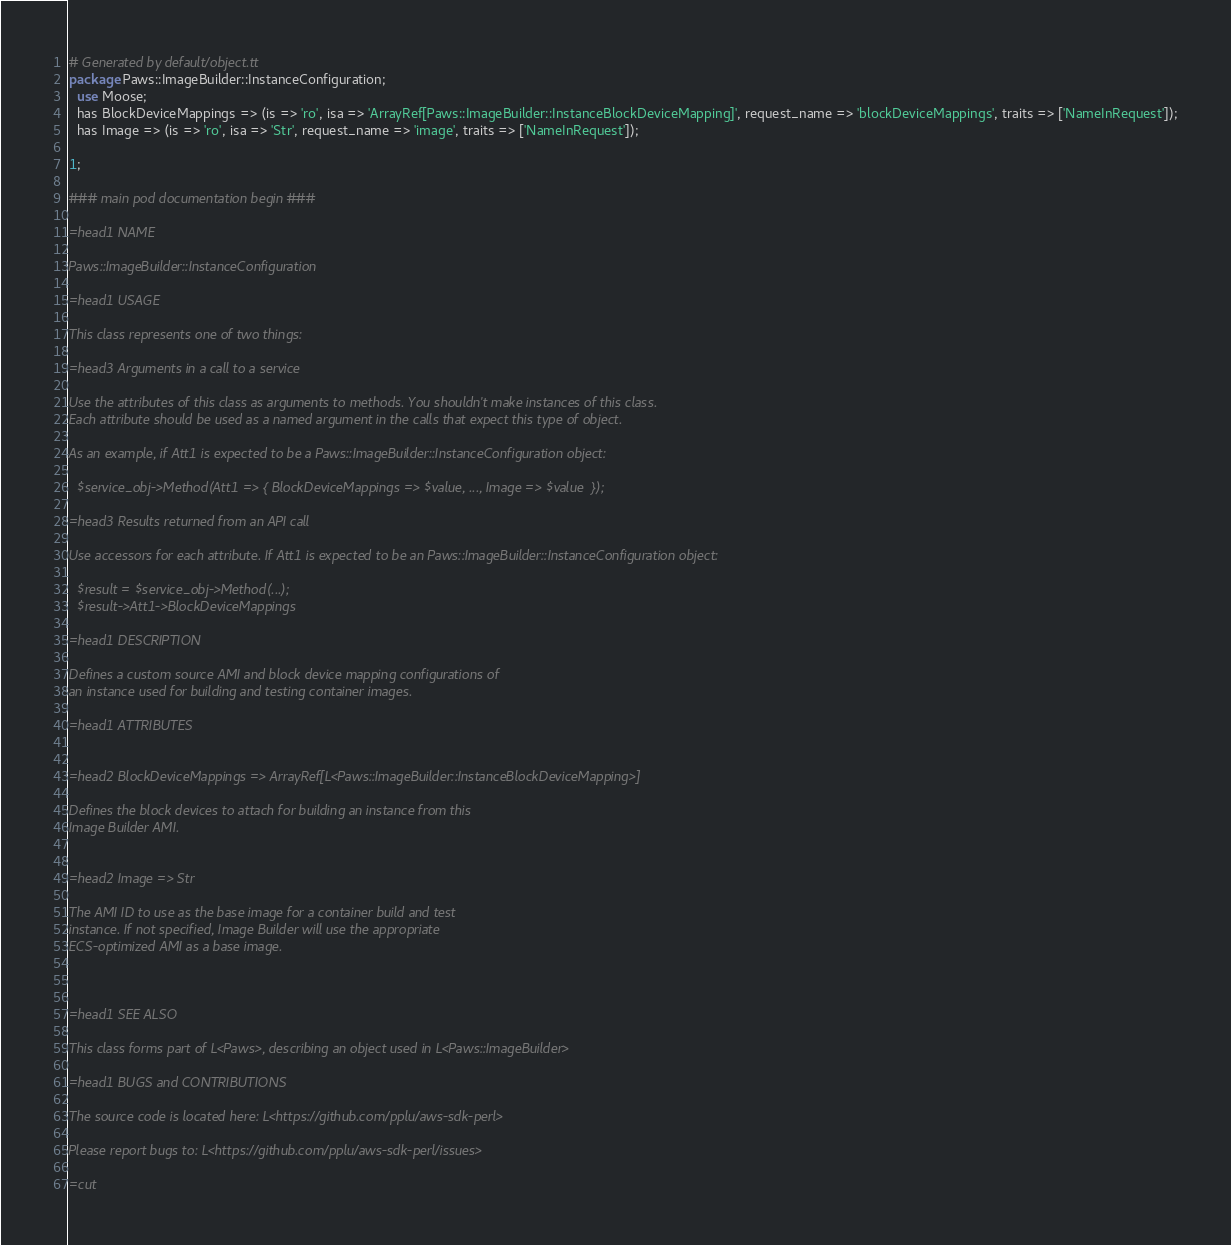Convert code to text. <code><loc_0><loc_0><loc_500><loc_500><_Perl_># Generated by default/object.tt
package Paws::ImageBuilder::InstanceConfiguration;
  use Moose;
  has BlockDeviceMappings => (is => 'ro', isa => 'ArrayRef[Paws::ImageBuilder::InstanceBlockDeviceMapping]', request_name => 'blockDeviceMappings', traits => ['NameInRequest']);
  has Image => (is => 'ro', isa => 'Str', request_name => 'image', traits => ['NameInRequest']);

1;

### main pod documentation begin ###

=head1 NAME

Paws::ImageBuilder::InstanceConfiguration

=head1 USAGE

This class represents one of two things:

=head3 Arguments in a call to a service

Use the attributes of this class as arguments to methods. You shouldn't make instances of this class. 
Each attribute should be used as a named argument in the calls that expect this type of object.

As an example, if Att1 is expected to be a Paws::ImageBuilder::InstanceConfiguration object:

  $service_obj->Method(Att1 => { BlockDeviceMappings => $value, ..., Image => $value  });

=head3 Results returned from an API call

Use accessors for each attribute. If Att1 is expected to be an Paws::ImageBuilder::InstanceConfiguration object:

  $result = $service_obj->Method(...);
  $result->Att1->BlockDeviceMappings

=head1 DESCRIPTION

Defines a custom source AMI and block device mapping configurations of
an instance used for building and testing container images.

=head1 ATTRIBUTES


=head2 BlockDeviceMappings => ArrayRef[L<Paws::ImageBuilder::InstanceBlockDeviceMapping>]

Defines the block devices to attach for building an instance from this
Image Builder AMI.


=head2 Image => Str

The AMI ID to use as the base image for a container build and test
instance. If not specified, Image Builder will use the appropriate
ECS-optimized AMI as a base image.



=head1 SEE ALSO

This class forms part of L<Paws>, describing an object used in L<Paws::ImageBuilder>

=head1 BUGS and CONTRIBUTIONS

The source code is located here: L<https://github.com/pplu/aws-sdk-perl>

Please report bugs to: L<https://github.com/pplu/aws-sdk-perl/issues>

=cut

</code> 